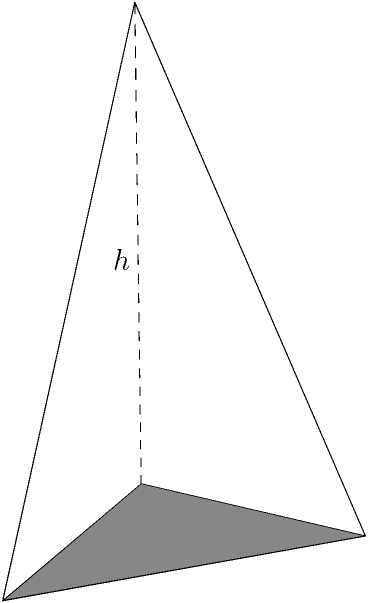As a speechwriter for political rallies, you've been tasked with designing a cone-shaped megaphone to amplify the speaker's voice. The megaphone has a radius of 6 inches at the base and a height of 15 inches. Calculate the volume of this megaphone in cubic inches, rounded to the nearest whole number. How might the volume affect the megaphone's effectiveness in projecting sound across a large political gathering? To calculate the volume of a cone-shaped megaphone, we'll use the formula for the volume of a cone:

$$V = \frac{1}{3}\pi r^2 h$$

Where:
$V$ = volume
$r$ = radius of the base
$h$ = height of the cone

Given:
$r = 6$ inches
$h = 15$ inches

Step 1: Substitute the values into the formula:
$$V = \frac{1}{3}\pi (6^2)(15)$$

Step 2: Simplify the expression:
$$V = \frac{1}{3}\pi (36)(15)$$
$$V = 5\pi(36)$$

Step 3: Calculate the result:
$$V = 180\pi \approx 565.49 \text{ cubic inches}$$

Step 4: Round to the nearest whole number:
$$V \approx 565 \text{ cubic inches}$$

The volume of the megaphone affects its effectiveness in projecting sound across a large political gathering. A larger volume generally allows for better amplification and sound projection. This cone-shaped design helps to focus and direct the sound waves, making it easier for the speaker's voice to reach a wider audience in an open-air setting typical of political rallies.
Answer: 565 cubic inches 